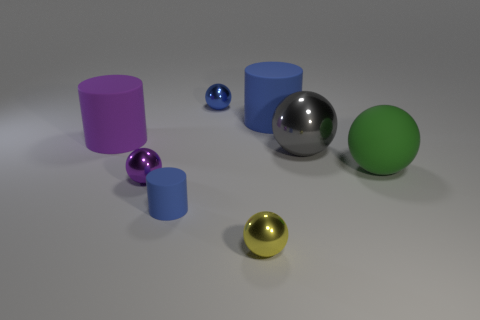Do the purple metallic sphere and the blue matte cylinder that is behind the big gray object have the same size?
Your response must be concise. No. Are there more yellow things that are to the right of the big gray sphere than big purple things?
Give a very brief answer. No. How many yellow objects have the same size as the blue shiny sphere?
Your answer should be compact. 1. There is a blue rubber thing in front of the big gray ball; is it the same size as the purple thing that is behind the large green rubber ball?
Your response must be concise. No. Is the number of matte cylinders that are behind the purple metal ball greater than the number of gray shiny spheres that are in front of the big gray metallic sphere?
Ensure brevity in your answer.  Yes. How many big purple matte objects have the same shape as the tiny matte thing?
Provide a short and direct response. 1. What material is the purple ball that is the same size as the yellow thing?
Provide a short and direct response. Metal. Is there a big cyan cylinder that has the same material as the gray thing?
Ensure brevity in your answer.  No. Is the number of blue cylinders on the left side of the big purple object less than the number of tiny purple matte cylinders?
Give a very brief answer. No. There is a big thing behind the object left of the purple sphere; what is it made of?
Offer a very short reply. Rubber. 